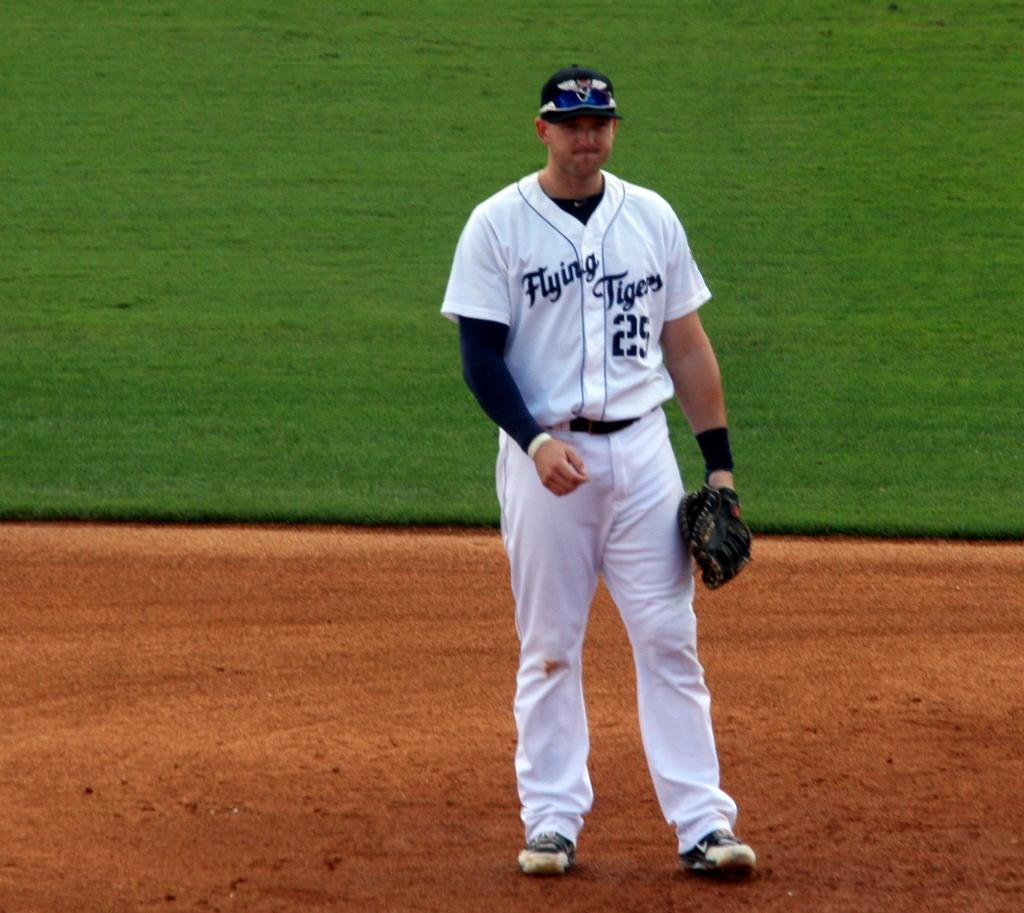<image>
Create a compact narrative representing the image presented. a baseball in a jersey with "flying tigers 25" on it is standing in a field 